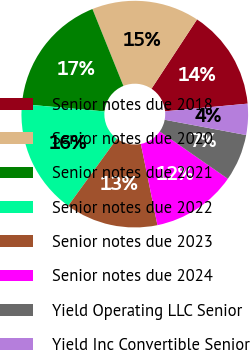Convert chart. <chart><loc_0><loc_0><loc_500><loc_500><pie_chart><fcel>Senior notes due 2018<fcel>Senior notes due 2020<fcel>Senior notes due 2021<fcel>Senior notes due 2022<fcel>Senior notes due 2023<fcel>Senior notes due 2024<fcel>Yield Operating LLC Senior<fcel>Yield Inc Convertible Senior<nl><fcel>14.27%<fcel>15.35%<fcel>17.49%<fcel>16.42%<fcel>13.2%<fcel>12.13%<fcel>6.71%<fcel>4.43%<nl></chart> 